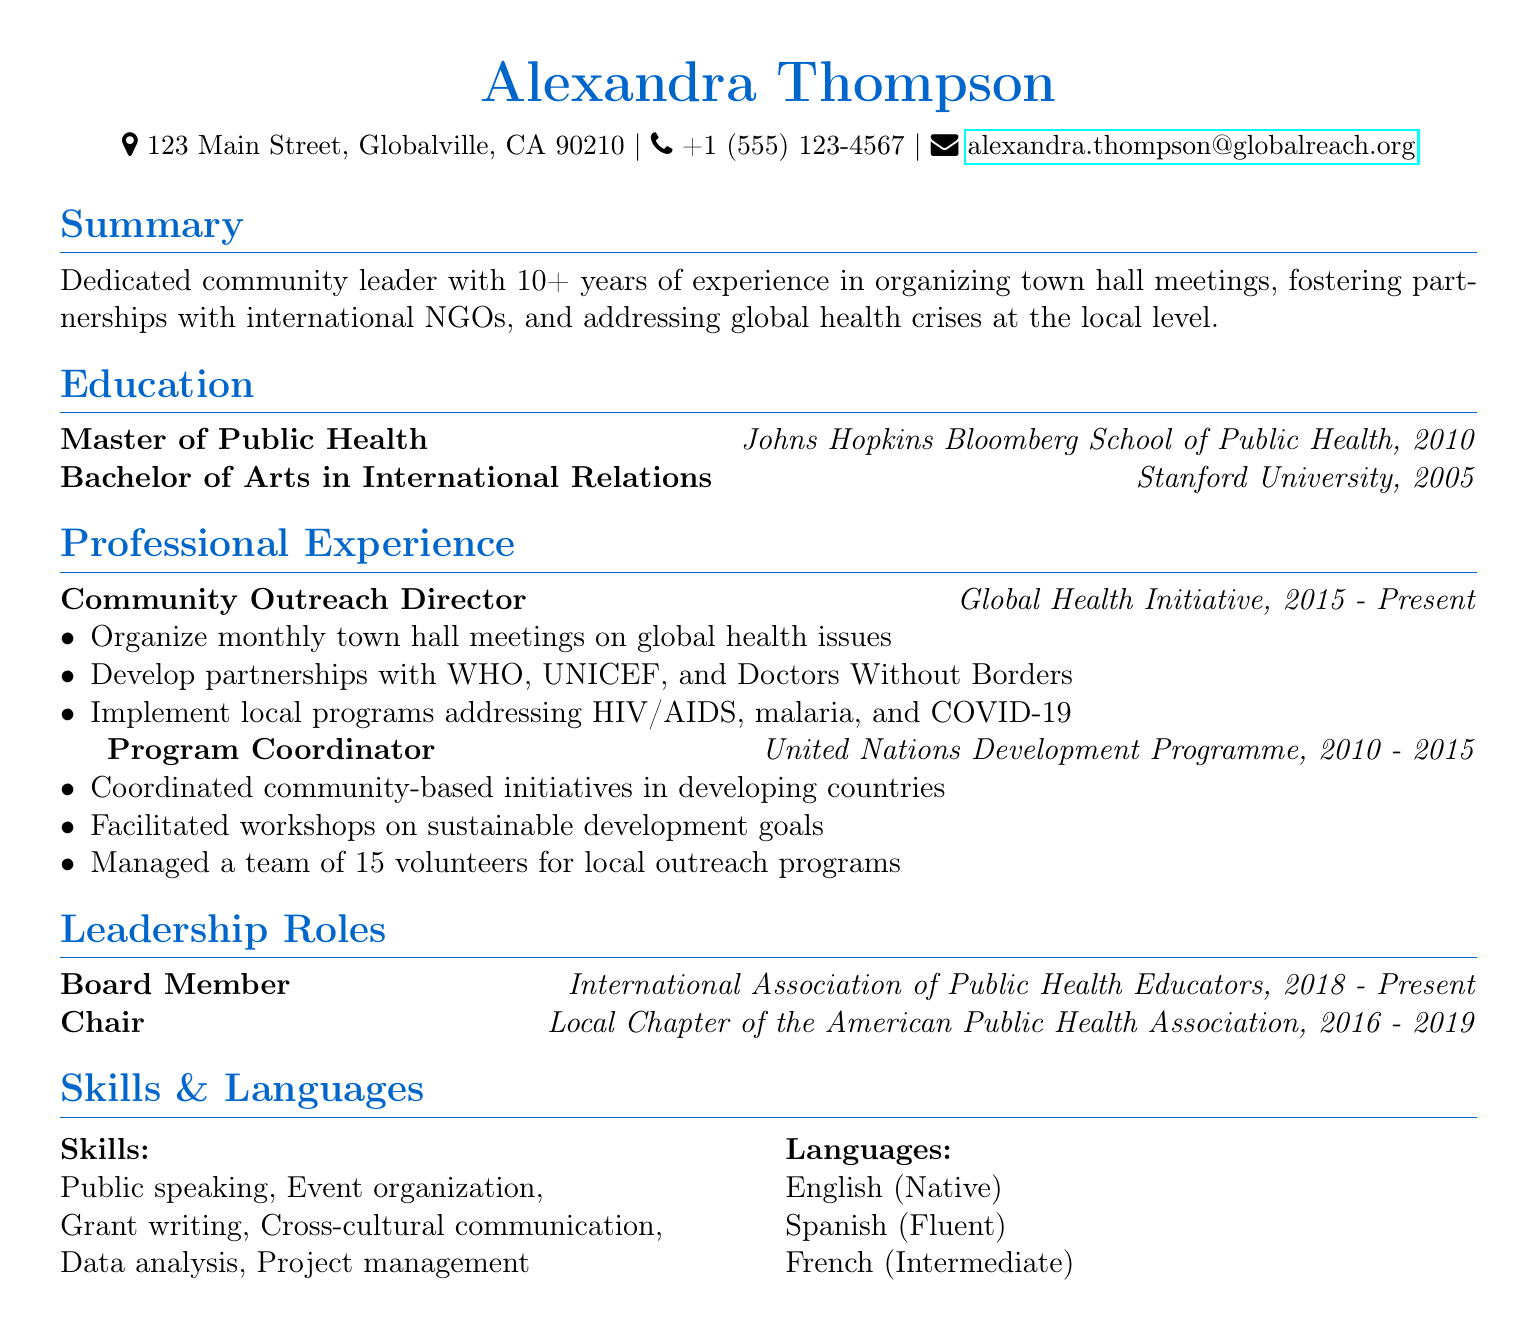What is the name of the individual? The name listed in the document is prominently displayed at the top.
Answer: Alexandra Thompson What degree did Alexandra Thompson earn at Johns Hopkins? The document specifies her educational background, including her degree from Johns Hopkins.
Answer: Master of Public Health What organization is Alexandra Thompson currently working for? This information is found under her professional experience section detailing her current role.
Answer: Global Health Initiative In what year did Alexandra Thompson start working as a Community Outreach Director? The document provides a timeline for her professional roles, indicating when she began her current position.
Answer: 2015 Who did Alexandra develop partnerships with in her current role? The document outlines her responsibilities, which include the names of specific organizations.
Answer: WHO, UNICEF, and Doctors Without Borders What was Alexandra's role at the Local Chapter of the American Public Health Association? This position is listed under her leadership roles and indicates her specific title.
Answer: Chair How many years of experience does Alexandra have in community leadership? The summary notes her total years of experience in community-related work.
Answer: 10+ What skills does Alexandra possess related to data? The skills section lists her abilities, including those specifically related to data.
Answer: Data analysis How many volunteers did Alexandra manage as a Program Coordinator? This information can be found under her previous job responsibilities.
Answer: 15 